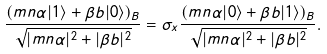Convert formula to latex. <formula><loc_0><loc_0><loc_500><loc_500>\frac { ( m n \alpha | 1 \rangle + \beta b | 0 \rangle ) _ { B } } { \sqrt { | m n \alpha | ^ { 2 } + | \beta b | ^ { 2 } } } = \sigma _ { x } \frac { ( m n \alpha | 0 \rangle + \beta b | 1 \rangle ) _ { B } } { \sqrt { | m n \alpha | ^ { 2 } + | \beta b | ^ { 2 } } } .</formula> 